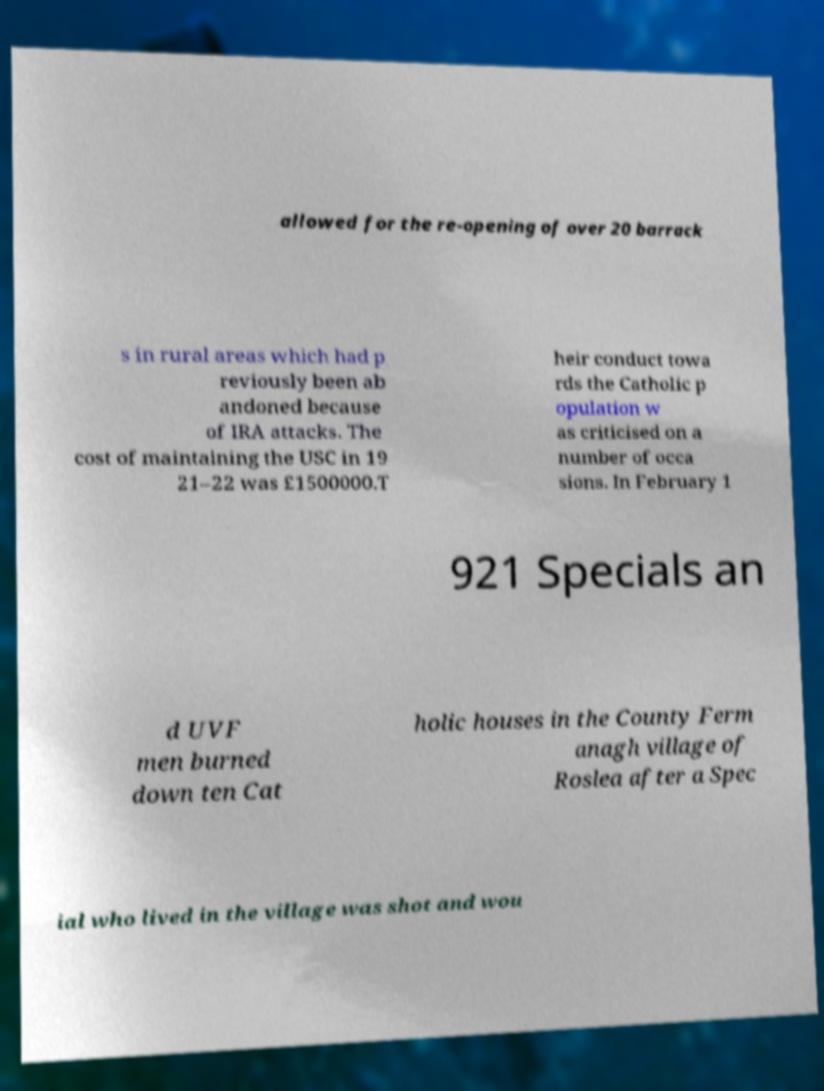Please identify and transcribe the text found in this image. allowed for the re-opening of over 20 barrack s in rural areas which had p reviously been ab andoned because of IRA attacks. The cost of maintaining the USC in 19 21–22 was £1500000.T heir conduct towa rds the Catholic p opulation w as criticised on a number of occa sions. In February 1 921 Specials an d UVF men burned down ten Cat holic houses in the County Ferm anagh village of Roslea after a Spec ial who lived in the village was shot and wou 